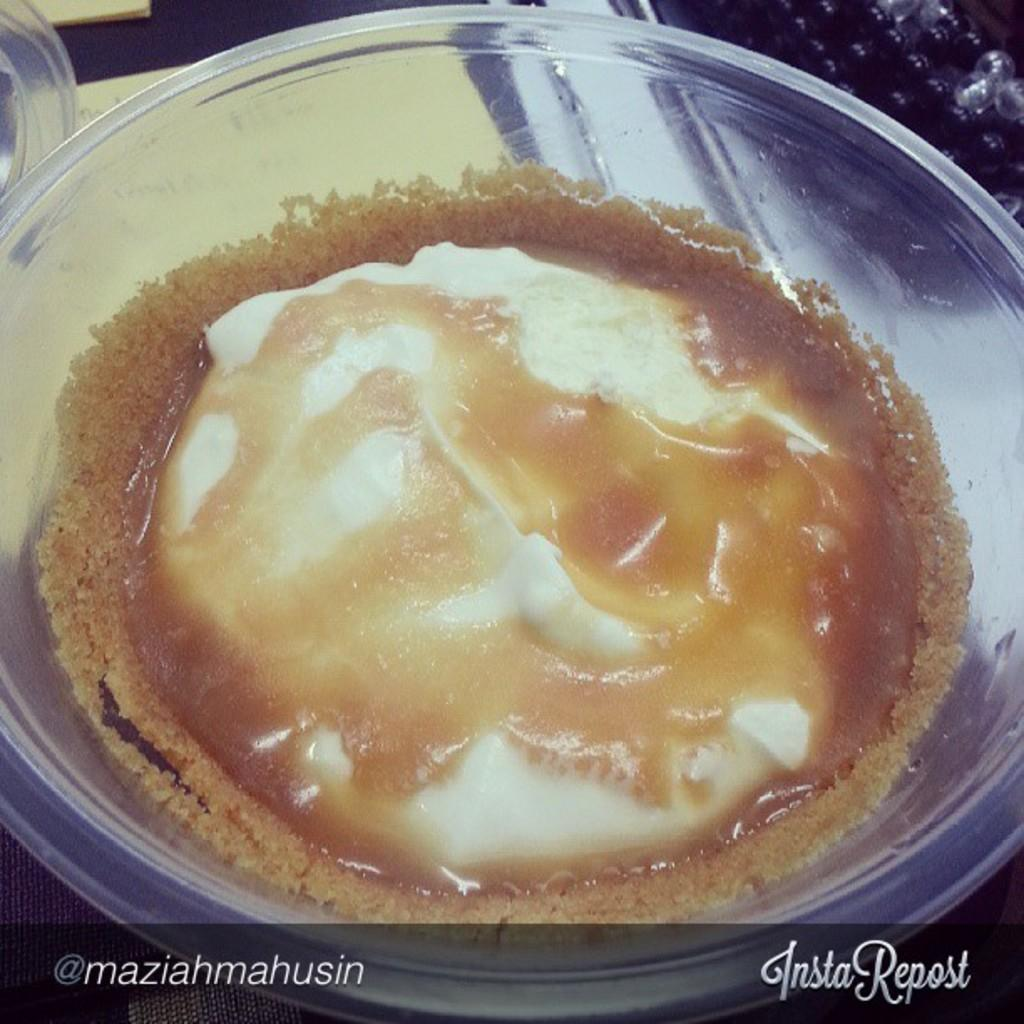What type of container is visible in the image? There is a glass bowl in the image. Where is the bowl located? The bowl is on a surface. What is inside the bowl? There is food in the bowl. What is placed beneath the bowl? There is a paper below the bowl. What can be found at the bottom of the image? There is text at the bottom of the image. What type of tax is being discussed in the image? There is no mention of taxes in the image; it features a glass bowl with food on a surface, a paper beneath it, and text at the bottom. 